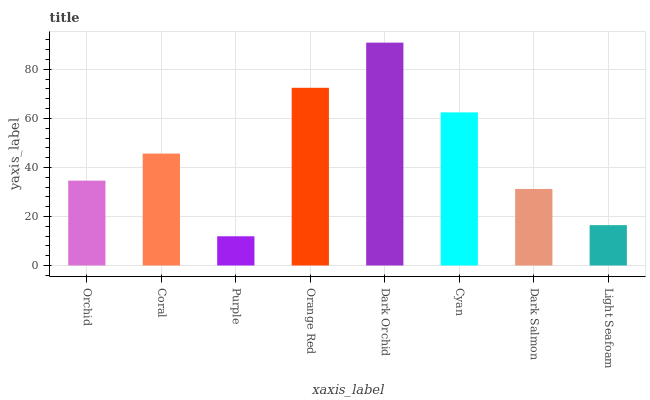Is Purple the minimum?
Answer yes or no. Yes. Is Dark Orchid the maximum?
Answer yes or no. Yes. Is Coral the minimum?
Answer yes or no. No. Is Coral the maximum?
Answer yes or no. No. Is Coral greater than Orchid?
Answer yes or no. Yes. Is Orchid less than Coral?
Answer yes or no. Yes. Is Orchid greater than Coral?
Answer yes or no. No. Is Coral less than Orchid?
Answer yes or no. No. Is Coral the high median?
Answer yes or no. Yes. Is Orchid the low median?
Answer yes or no. Yes. Is Cyan the high median?
Answer yes or no. No. Is Dark Salmon the low median?
Answer yes or no. No. 